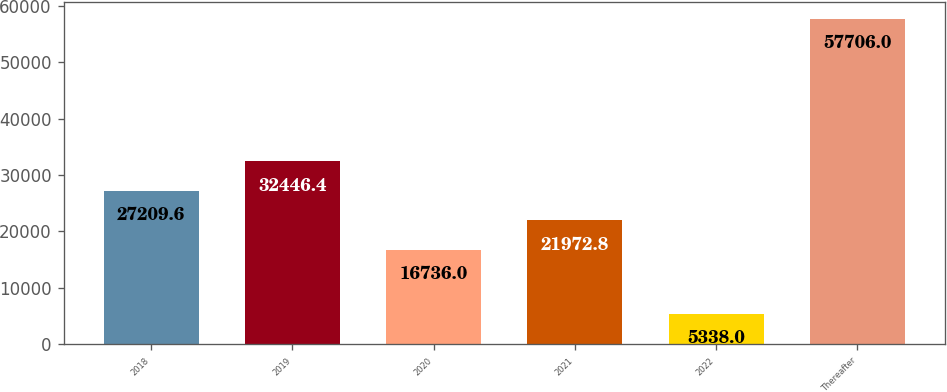Convert chart to OTSL. <chart><loc_0><loc_0><loc_500><loc_500><bar_chart><fcel>2018<fcel>2019<fcel>2020<fcel>2021<fcel>2022<fcel>Thereafter<nl><fcel>27209.6<fcel>32446.4<fcel>16736<fcel>21972.8<fcel>5338<fcel>57706<nl></chart> 